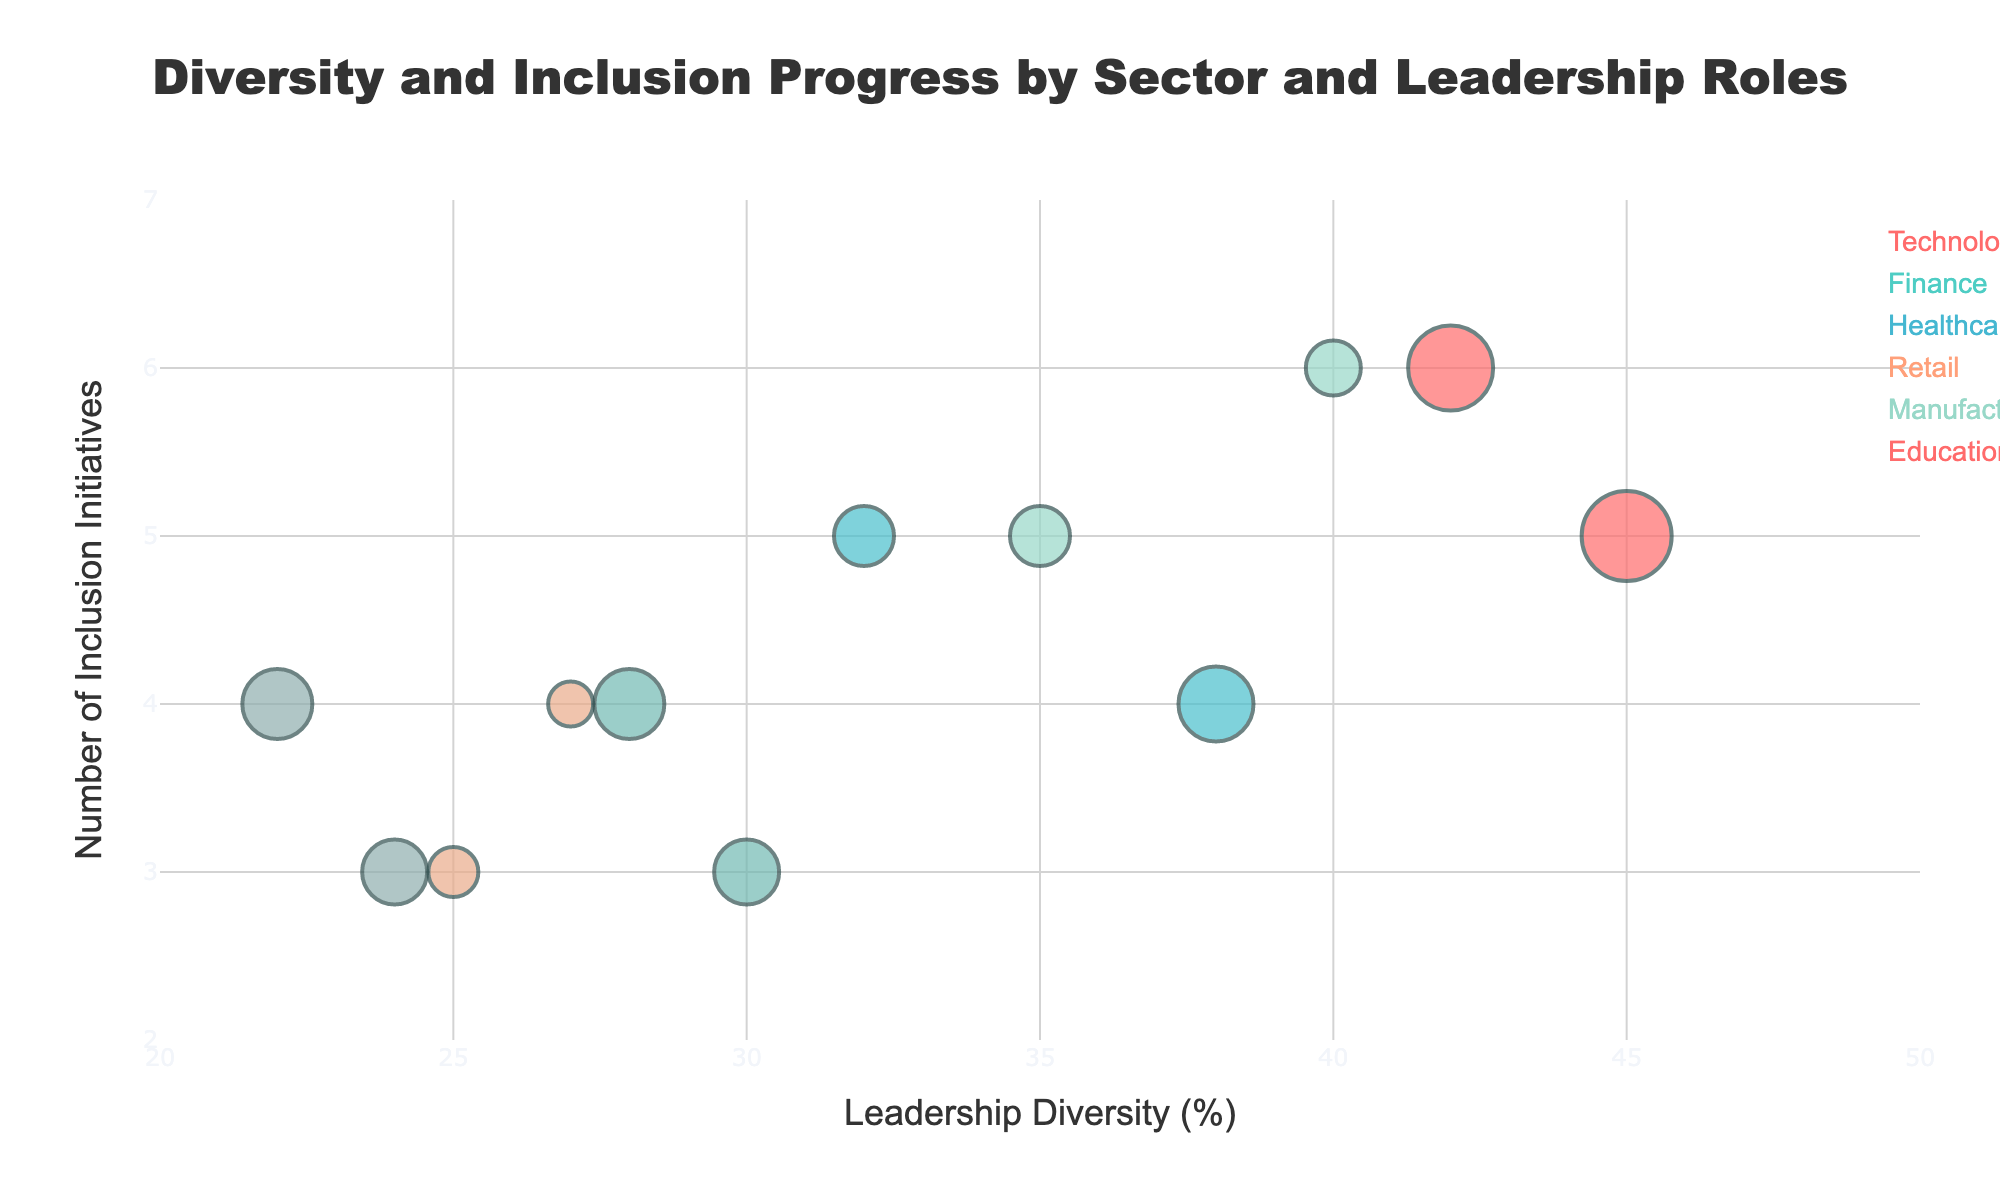Which sector has the highest percentage of leadership diversity? Look at the x-axis for Leadership Diversity (%). The highest value corresponds to Harvard University in the Education sector which has 45%.
Answer: Education How many inclusion initiatives does Microsoft have compared to Google? Check the y-axis for Inclusion Initiatives (number). Microsoft has 6 initiatives, while Google has 5.
Answer: Microsoft: 6, Google: 5 Which company has the smallest average tenure of diverse leaders? Compare the size of the bubbles. The smallest bubble corresponds to Target, with an average tenure of 4.5 years.
Answer: Target What's the average inclusion initiatives number in the Healthcare sector? Healthcare companies are Johnson & Johnson (4 initiatives) and Pfizer (5 initiatives). The average is (4+5)/2 = 4.5.
Answer: 4.5 Which sector seems to lag in both leadership diversity and inclusion initiatives? Look for sectors with low x and y values. Manufacturing companies (General Electric and 3M) have the lowest combined leadership diversity and low inclusion initiatives (22-24%) and (3-4 initiatives).
Answer: Manufacturing Has any sector achieved inclusion initiatives above five while maintaining leadership diversity over 40%? Look for bubbles with y > 5 and x > 40. Stanford University in Education sector fits this criterion with 42% diversity and 6 initiatives.
Answer: Education How does the Tenure of Diverse Leaders in Retail compare to Technology? Retail companies (Walmart and Target) have average tenures of 5 and 4.5 years. Technology companies (Google and Microsoft) have 6 and 5.5 years. Technology has a higher average tenure.
Answer: Technology Are there sectors that have similar Inclusion Initiative numbers but very different Leadership Diversity percentages? Compare y-axis values. For instance, both Technology and Healthcare sectors have companies with around 5 inclusion initiatives but diversity percentages range from 32% to 40%.
Answer: Yes Which company has the largest bubble size in the figure? The largest bubble corresponds to Harvard University with an average tenure of diverse leaders of 9 years.
Answer: Harvard University 